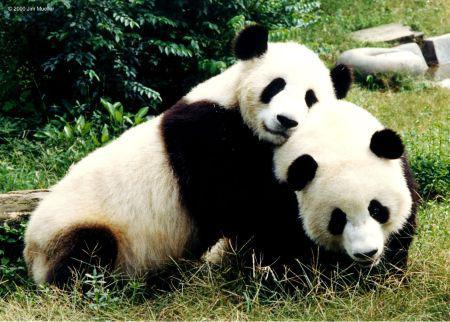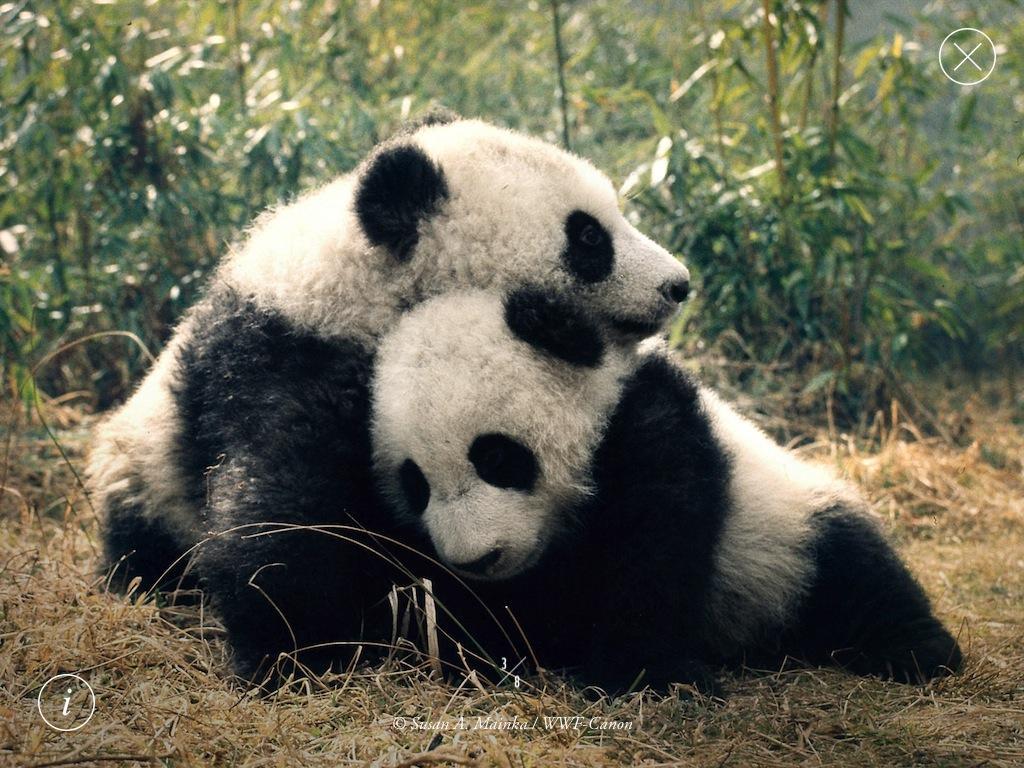The first image is the image on the left, the second image is the image on the right. Analyze the images presented: Is the assertion "There are no panda-pups in the left image." valid? Answer yes or no. Yes. 